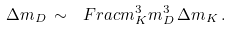Convert formula to latex. <formula><loc_0><loc_0><loc_500><loc_500>\Delta m _ { D } \, \sim \, \ F r a c { m _ { K } ^ { 3 } } { m _ { D } ^ { 3 } } \, \Delta m _ { K } \, .</formula> 